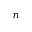<formula> <loc_0><loc_0><loc_500><loc_500>n</formula> 